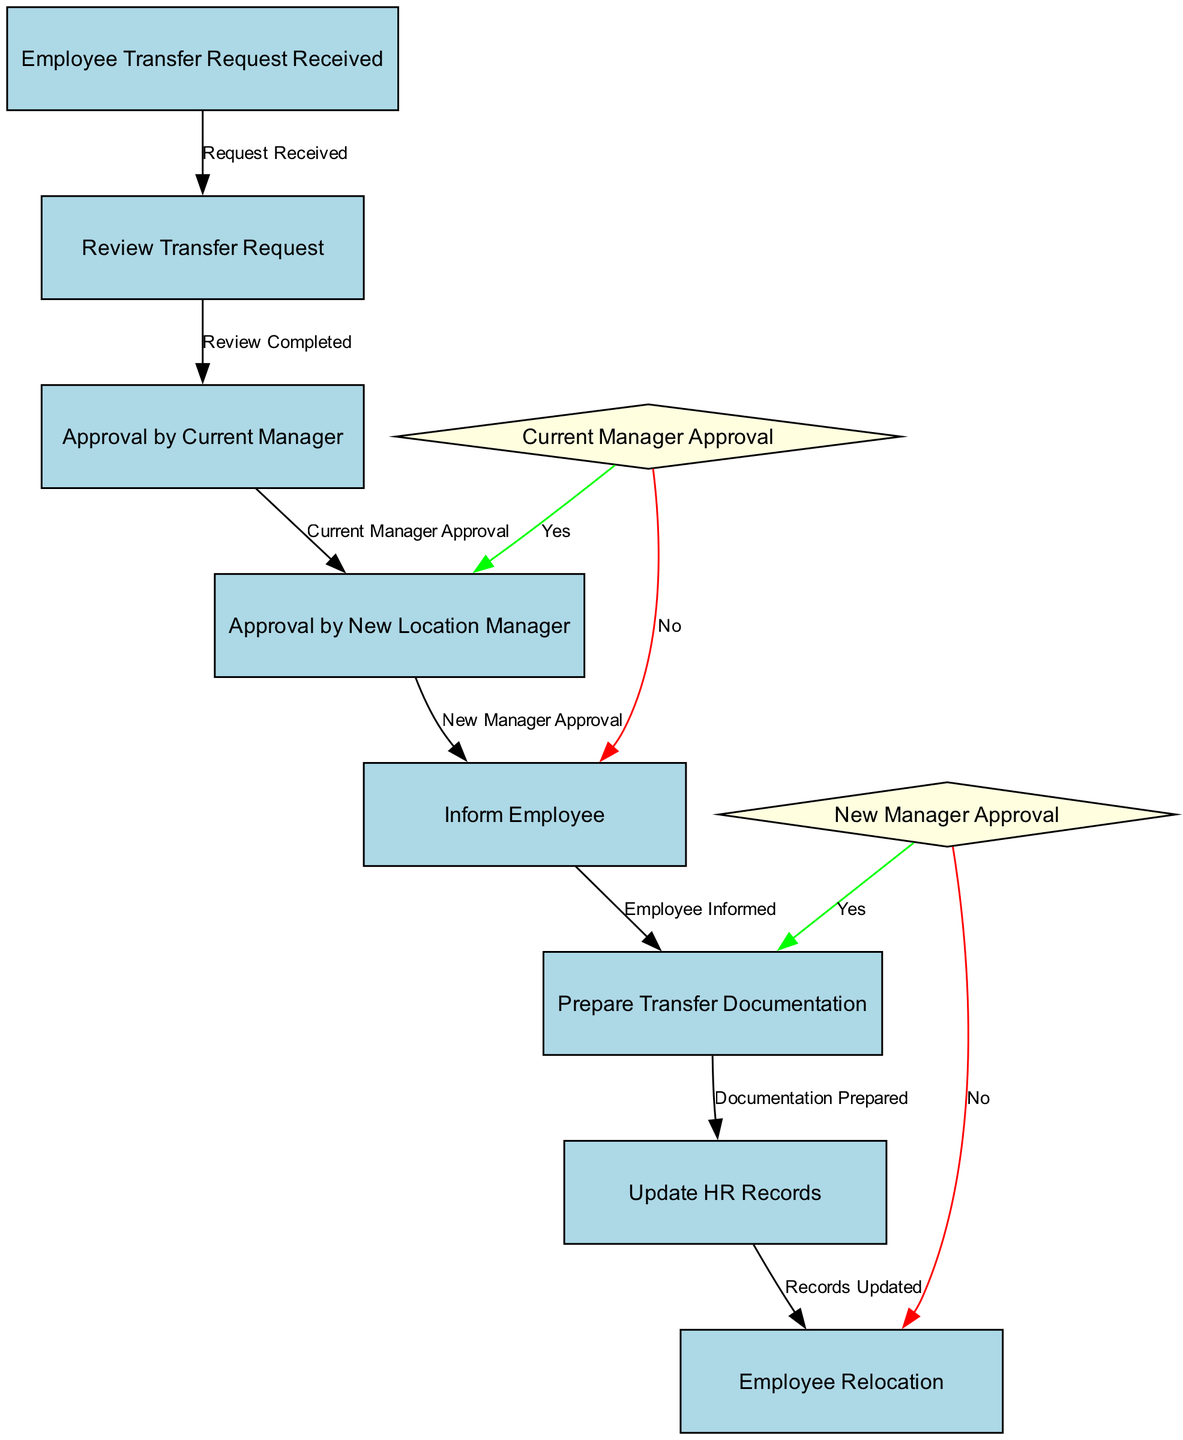What is the first step in the transfer process? The diagram begins with the node labeled "Employee Transfer Request Received," indicating that this is the initial step of the process.
Answer: Employee Transfer Request Received How many decision points are in the diagram? The diagram includes two decision points: "Current Manager Approval" and "New Manager Approval." Therefore, the total is two.
Answer: 2 What happens after the "Review Transfer Request"? Following the "Review Transfer Request," there is a flow leading to the "Current Manager Approval," which is the subsequent step in the process.
Answer: Current Manager Approval What is the outcome if the "Current Manager Approval" is declined? If the "Current Manager Approval" is declined, the flow indicates that the process moves to the "Inform Employee" step, which is the path taken when the approval is not granted.
Answer: Inform Employee What is the total number of edges in the diagram? The diagram lists seven edges that represent the flow from one step to another, detailing the progress through the process.
Answer: 7 What step follows after "Prepare Transfer Documentation"? The step that follows "Prepare Transfer Documentation" is "Update HR Records," which directly follows the completion of documentation preparation.
Answer: Update HR Records What color are the decision point nodes represented in the diagram? The decision point nodes are displayed in light yellow, as indicated by the coloring scheme defined for them in the diagram.
Answer: Light yellow What happens if the "New Manager Approval" is declined? If the "New Manager Approval" is declined, the flow reveals that it leads directly to the "Employee Relocation," which indicates the end of the transfer process despite the prior approval being necessary.
Answer: Employee Relocation 